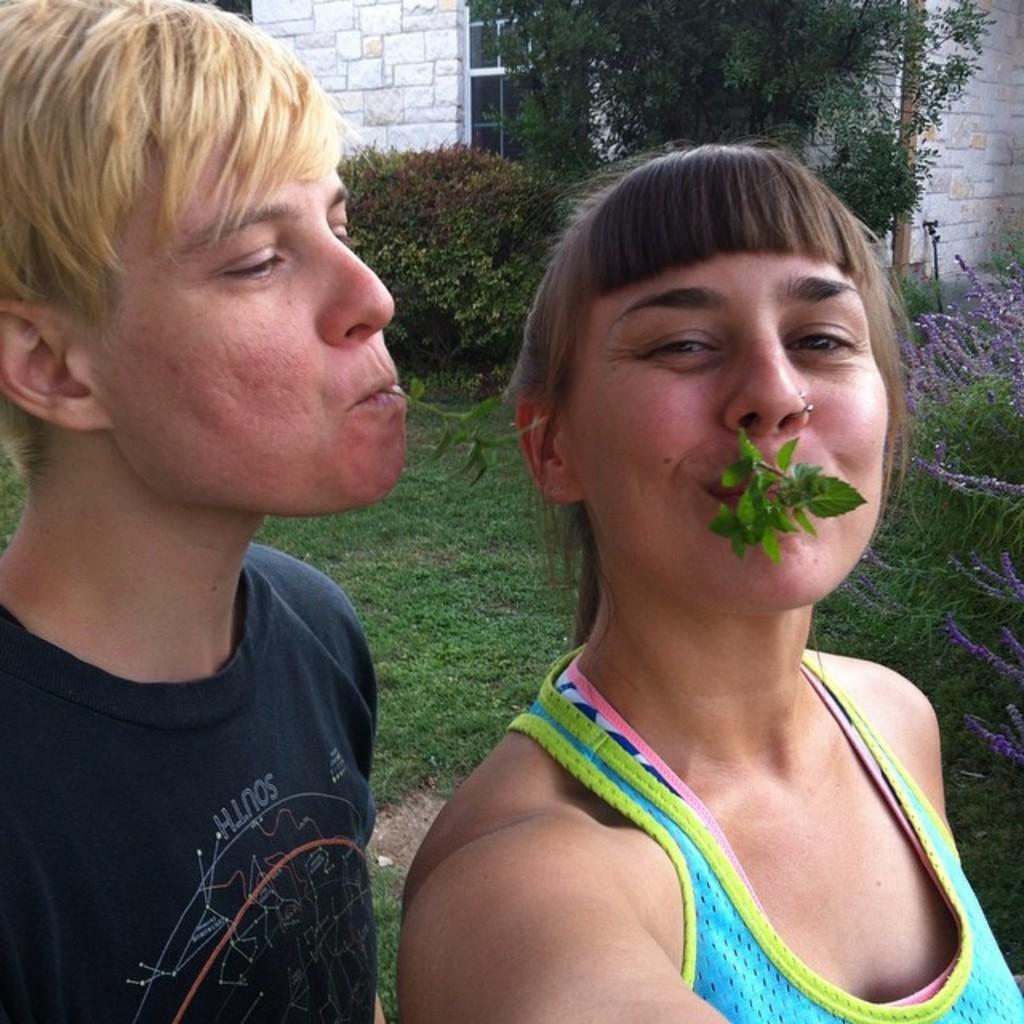Could you give a brief overview of what you see in this image? As we can see in the image there is grass, plants, trees, windows and building. In the front there are two people standing. The man on the left side is wearing black color t shirt. The woman on the right side is wearing sky blue color dress. 